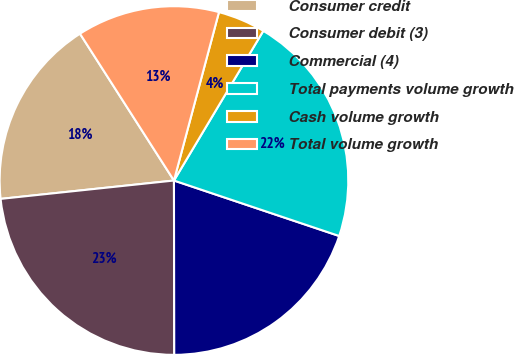<chart> <loc_0><loc_0><loc_500><loc_500><pie_chart><fcel>Consumer credit<fcel>Consumer debit (3)<fcel>Commercial (4)<fcel>Total payments volume growth<fcel>Cash volume growth<fcel>Total volume growth<nl><fcel>17.62%<fcel>23.35%<fcel>19.82%<fcel>21.59%<fcel>4.41%<fcel>13.22%<nl></chart> 